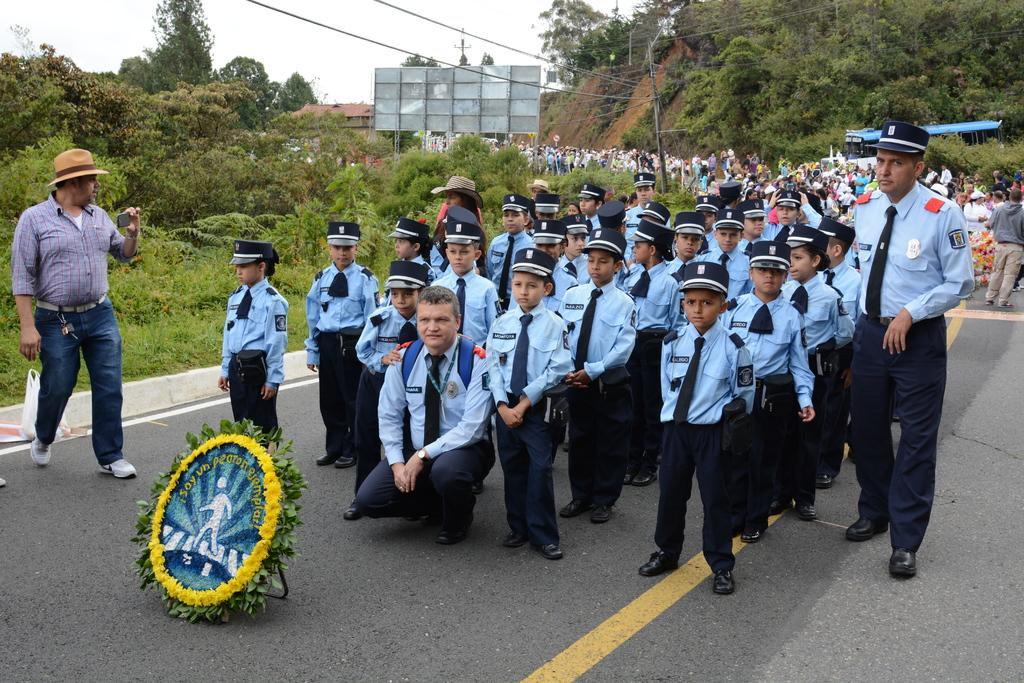What are the people in the image doing? There is a group of people standing on the road in the image. What object can be seen in the image that is typically used for protection? There is a shield visible in the image. What type of vegetation is present in the image? Trees are present in the image. What type of covering is visible in the image? A plastic cover is visible in the image. What type of signage is present in the image? There is a hoarding in the image. What type of infrastructure is present in the image? Wires are present in the image. What can be seen in the background of the image? The sky is visible in the background of the image. What type of pies are being sold at the hoarding in the image? There is no indication of pies being sold or present in the image. What scent can be detected in the image? The image does not provide any information about scents, as it is a visual medium. 